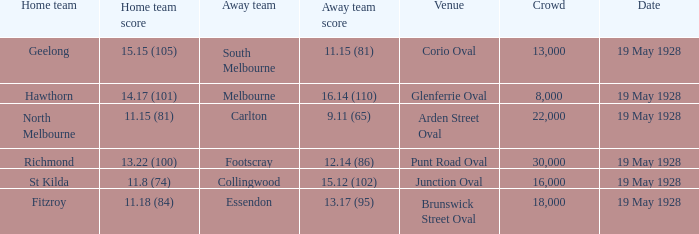What venue featured a crowd of over 30,000? None. 